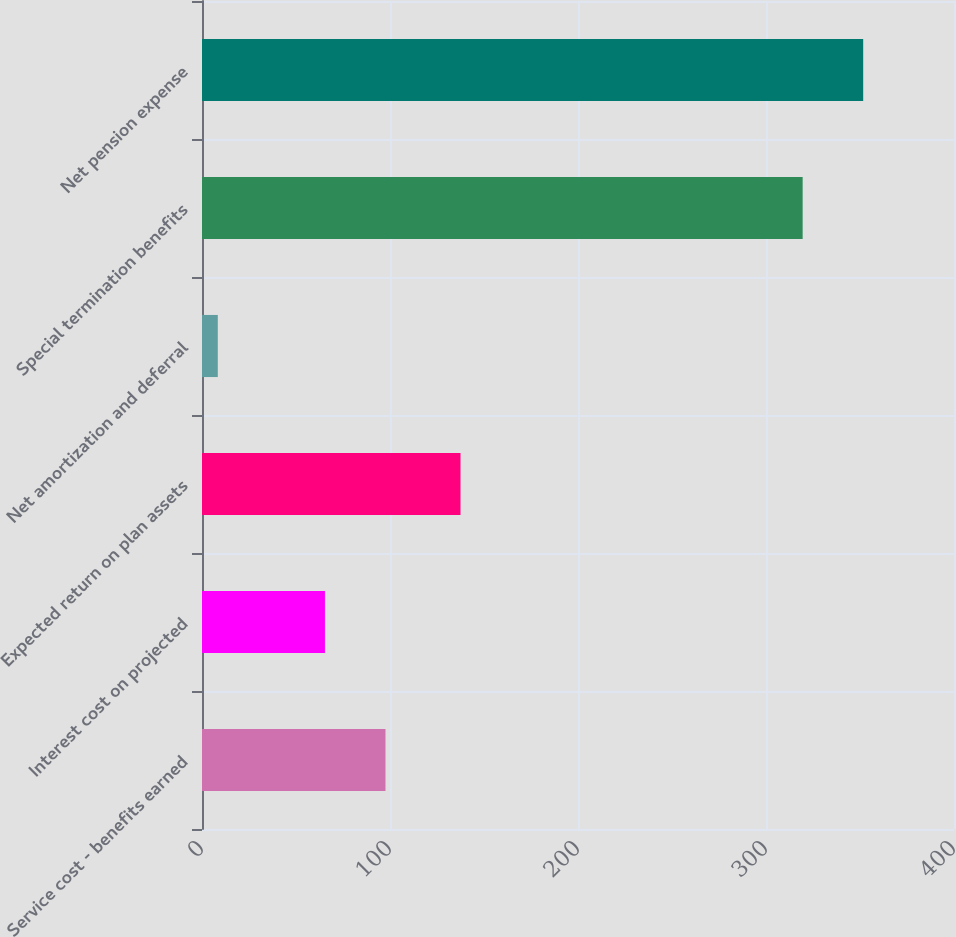Convert chart to OTSL. <chart><loc_0><loc_0><loc_500><loc_500><bar_chart><fcel>Service cost - benefits earned<fcel>Interest cost on projected<fcel>Expected return on plan assets<fcel>Net amortization and deferral<fcel>Special termination benefits<fcel>Net pension expense<nl><fcel>97.6<fcel>65.4<fcel>137.5<fcel>8.4<fcel>319.5<fcel>351.7<nl></chart> 